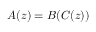<formula> <loc_0><loc_0><loc_500><loc_500>A ( z ) = B ( C ( z ) )</formula> 